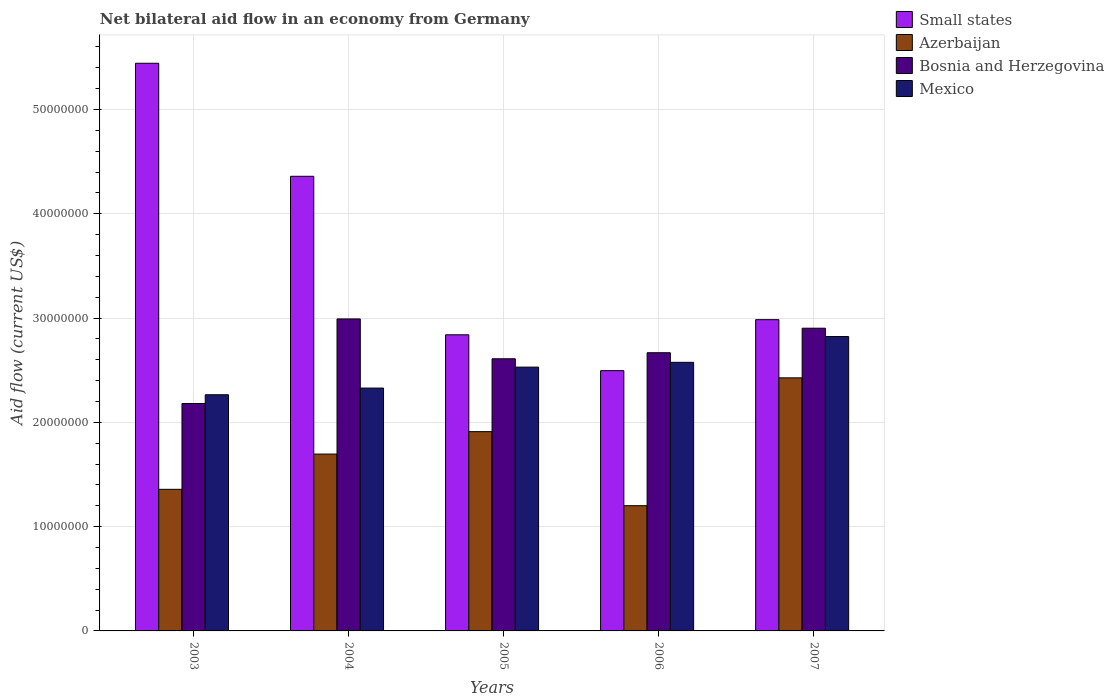How many different coloured bars are there?
Keep it short and to the point. 4. How many bars are there on the 3rd tick from the left?
Your answer should be compact. 4. What is the label of the 1st group of bars from the left?
Offer a very short reply. 2003. In how many cases, is the number of bars for a given year not equal to the number of legend labels?
Provide a succinct answer. 0. What is the net bilateral aid flow in Small states in 2006?
Keep it short and to the point. 2.50e+07. Across all years, what is the maximum net bilateral aid flow in Small states?
Give a very brief answer. 5.44e+07. Across all years, what is the minimum net bilateral aid flow in Small states?
Provide a short and direct response. 2.50e+07. What is the total net bilateral aid flow in Small states in the graph?
Ensure brevity in your answer.  1.81e+08. What is the difference between the net bilateral aid flow in Azerbaijan in 2003 and that in 2006?
Your answer should be very brief. 1.57e+06. What is the difference between the net bilateral aid flow in Mexico in 2005 and the net bilateral aid flow in Bosnia and Herzegovina in 2004?
Provide a short and direct response. -4.62e+06. What is the average net bilateral aid flow in Mexico per year?
Keep it short and to the point. 2.50e+07. In the year 2004, what is the difference between the net bilateral aid flow in Azerbaijan and net bilateral aid flow in Mexico?
Your answer should be very brief. -6.33e+06. In how many years, is the net bilateral aid flow in Bosnia and Herzegovina greater than 16000000 US$?
Make the answer very short. 5. What is the ratio of the net bilateral aid flow in Bosnia and Herzegovina in 2004 to that in 2006?
Your answer should be compact. 1.12. Is the net bilateral aid flow in Bosnia and Herzegovina in 2005 less than that in 2006?
Offer a terse response. Yes. What is the difference between the highest and the second highest net bilateral aid flow in Bosnia and Herzegovina?
Make the answer very short. 8.90e+05. What is the difference between the highest and the lowest net bilateral aid flow in Mexico?
Your answer should be very brief. 5.58e+06. In how many years, is the net bilateral aid flow in Small states greater than the average net bilateral aid flow in Small states taken over all years?
Provide a short and direct response. 2. Is the sum of the net bilateral aid flow in Small states in 2006 and 2007 greater than the maximum net bilateral aid flow in Azerbaijan across all years?
Ensure brevity in your answer.  Yes. Is it the case that in every year, the sum of the net bilateral aid flow in Bosnia and Herzegovina and net bilateral aid flow in Small states is greater than the sum of net bilateral aid flow in Mexico and net bilateral aid flow in Azerbaijan?
Provide a succinct answer. Yes. What does the 4th bar from the left in 2005 represents?
Give a very brief answer. Mexico. What does the 3rd bar from the right in 2007 represents?
Your response must be concise. Azerbaijan. Are all the bars in the graph horizontal?
Keep it short and to the point. No. Are the values on the major ticks of Y-axis written in scientific E-notation?
Your answer should be compact. No. Does the graph contain grids?
Ensure brevity in your answer.  Yes. How many legend labels are there?
Provide a succinct answer. 4. How are the legend labels stacked?
Offer a very short reply. Vertical. What is the title of the graph?
Your answer should be very brief. Net bilateral aid flow in an economy from Germany. What is the label or title of the Y-axis?
Keep it short and to the point. Aid flow (current US$). What is the Aid flow (current US$) of Small states in 2003?
Your response must be concise. 5.44e+07. What is the Aid flow (current US$) in Azerbaijan in 2003?
Offer a terse response. 1.36e+07. What is the Aid flow (current US$) of Bosnia and Herzegovina in 2003?
Your response must be concise. 2.18e+07. What is the Aid flow (current US$) of Mexico in 2003?
Provide a succinct answer. 2.26e+07. What is the Aid flow (current US$) of Small states in 2004?
Ensure brevity in your answer.  4.36e+07. What is the Aid flow (current US$) of Azerbaijan in 2004?
Ensure brevity in your answer.  1.70e+07. What is the Aid flow (current US$) in Bosnia and Herzegovina in 2004?
Keep it short and to the point. 2.99e+07. What is the Aid flow (current US$) in Mexico in 2004?
Give a very brief answer. 2.33e+07. What is the Aid flow (current US$) in Small states in 2005?
Keep it short and to the point. 2.84e+07. What is the Aid flow (current US$) of Azerbaijan in 2005?
Offer a terse response. 1.91e+07. What is the Aid flow (current US$) in Bosnia and Herzegovina in 2005?
Provide a short and direct response. 2.61e+07. What is the Aid flow (current US$) in Mexico in 2005?
Give a very brief answer. 2.53e+07. What is the Aid flow (current US$) in Small states in 2006?
Provide a succinct answer. 2.50e+07. What is the Aid flow (current US$) of Azerbaijan in 2006?
Provide a succinct answer. 1.20e+07. What is the Aid flow (current US$) in Bosnia and Herzegovina in 2006?
Offer a very short reply. 2.67e+07. What is the Aid flow (current US$) of Mexico in 2006?
Provide a short and direct response. 2.58e+07. What is the Aid flow (current US$) in Small states in 2007?
Your response must be concise. 2.98e+07. What is the Aid flow (current US$) of Azerbaijan in 2007?
Make the answer very short. 2.43e+07. What is the Aid flow (current US$) in Bosnia and Herzegovina in 2007?
Make the answer very short. 2.90e+07. What is the Aid flow (current US$) of Mexico in 2007?
Offer a terse response. 2.82e+07. Across all years, what is the maximum Aid flow (current US$) of Small states?
Your answer should be very brief. 5.44e+07. Across all years, what is the maximum Aid flow (current US$) of Azerbaijan?
Provide a succinct answer. 2.43e+07. Across all years, what is the maximum Aid flow (current US$) of Bosnia and Herzegovina?
Give a very brief answer. 2.99e+07. Across all years, what is the maximum Aid flow (current US$) of Mexico?
Make the answer very short. 2.82e+07. Across all years, what is the minimum Aid flow (current US$) of Small states?
Ensure brevity in your answer.  2.50e+07. Across all years, what is the minimum Aid flow (current US$) of Azerbaijan?
Make the answer very short. 1.20e+07. Across all years, what is the minimum Aid flow (current US$) in Bosnia and Herzegovina?
Your answer should be compact. 2.18e+07. Across all years, what is the minimum Aid flow (current US$) in Mexico?
Give a very brief answer. 2.26e+07. What is the total Aid flow (current US$) in Small states in the graph?
Offer a very short reply. 1.81e+08. What is the total Aid flow (current US$) of Azerbaijan in the graph?
Make the answer very short. 8.59e+07. What is the total Aid flow (current US$) in Bosnia and Herzegovina in the graph?
Make the answer very short. 1.34e+08. What is the total Aid flow (current US$) of Mexico in the graph?
Your answer should be very brief. 1.25e+08. What is the difference between the Aid flow (current US$) in Small states in 2003 and that in 2004?
Offer a very short reply. 1.08e+07. What is the difference between the Aid flow (current US$) in Azerbaijan in 2003 and that in 2004?
Keep it short and to the point. -3.38e+06. What is the difference between the Aid flow (current US$) of Bosnia and Herzegovina in 2003 and that in 2004?
Ensure brevity in your answer.  -8.11e+06. What is the difference between the Aid flow (current US$) of Mexico in 2003 and that in 2004?
Give a very brief answer. -6.40e+05. What is the difference between the Aid flow (current US$) of Small states in 2003 and that in 2005?
Provide a short and direct response. 2.60e+07. What is the difference between the Aid flow (current US$) in Azerbaijan in 2003 and that in 2005?
Give a very brief answer. -5.53e+06. What is the difference between the Aid flow (current US$) in Bosnia and Herzegovina in 2003 and that in 2005?
Make the answer very short. -4.29e+06. What is the difference between the Aid flow (current US$) of Mexico in 2003 and that in 2005?
Your answer should be compact. -2.65e+06. What is the difference between the Aid flow (current US$) in Small states in 2003 and that in 2006?
Your answer should be compact. 2.95e+07. What is the difference between the Aid flow (current US$) in Azerbaijan in 2003 and that in 2006?
Give a very brief answer. 1.57e+06. What is the difference between the Aid flow (current US$) in Bosnia and Herzegovina in 2003 and that in 2006?
Give a very brief answer. -4.87e+06. What is the difference between the Aid flow (current US$) in Mexico in 2003 and that in 2006?
Your answer should be compact. -3.11e+06. What is the difference between the Aid flow (current US$) in Small states in 2003 and that in 2007?
Give a very brief answer. 2.46e+07. What is the difference between the Aid flow (current US$) in Azerbaijan in 2003 and that in 2007?
Make the answer very short. -1.07e+07. What is the difference between the Aid flow (current US$) of Bosnia and Herzegovina in 2003 and that in 2007?
Offer a terse response. -7.22e+06. What is the difference between the Aid flow (current US$) in Mexico in 2003 and that in 2007?
Keep it short and to the point. -5.58e+06. What is the difference between the Aid flow (current US$) of Small states in 2004 and that in 2005?
Your response must be concise. 1.52e+07. What is the difference between the Aid flow (current US$) in Azerbaijan in 2004 and that in 2005?
Keep it short and to the point. -2.15e+06. What is the difference between the Aid flow (current US$) in Bosnia and Herzegovina in 2004 and that in 2005?
Offer a terse response. 3.82e+06. What is the difference between the Aid flow (current US$) of Mexico in 2004 and that in 2005?
Ensure brevity in your answer.  -2.01e+06. What is the difference between the Aid flow (current US$) of Small states in 2004 and that in 2006?
Your answer should be compact. 1.86e+07. What is the difference between the Aid flow (current US$) in Azerbaijan in 2004 and that in 2006?
Make the answer very short. 4.95e+06. What is the difference between the Aid flow (current US$) of Bosnia and Herzegovina in 2004 and that in 2006?
Provide a succinct answer. 3.24e+06. What is the difference between the Aid flow (current US$) of Mexico in 2004 and that in 2006?
Provide a succinct answer. -2.47e+06. What is the difference between the Aid flow (current US$) in Small states in 2004 and that in 2007?
Keep it short and to the point. 1.38e+07. What is the difference between the Aid flow (current US$) in Azerbaijan in 2004 and that in 2007?
Offer a very short reply. -7.31e+06. What is the difference between the Aid flow (current US$) in Bosnia and Herzegovina in 2004 and that in 2007?
Offer a terse response. 8.90e+05. What is the difference between the Aid flow (current US$) of Mexico in 2004 and that in 2007?
Give a very brief answer. -4.94e+06. What is the difference between the Aid flow (current US$) of Small states in 2005 and that in 2006?
Offer a very short reply. 3.44e+06. What is the difference between the Aid flow (current US$) of Azerbaijan in 2005 and that in 2006?
Offer a very short reply. 7.10e+06. What is the difference between the Aid flow (current US$) in Bosnia and Herzegovina in 2005 and that in 2006?
Offer a very short reply. -5.80e+05. What is the difference between the Aid flow (current US$) in Mexico in 2005 and that in 2006?
Keep it short and to the point. -4.60e+05. What is the difference between the Aid flow (current US$) in Small states in 2005 and that in 2007?
Provide a succinct answer. -1.45e+06. What is the difference between the Aid flow (current US$) of Azerbaijan in 2005 and that in 2007?
Your answer should be compact. -5.16e+06. What is the difference between the Aid flow (current US$) of Bosnia and Herzegovina in 2005 and that in 2007?
Provide a succinct answer. -2.93e+06. What is the difference between the Aid flow (current US$) in Mexico in 2005 and that in 2007?
Your response must be concise. -2.93e+06. What is the difference between the Aid flow (current US$) of Small states in 2006 and that in 2007?
Your answer should be very brief. -4.89e+06. What is the difference between the Aid flow (current US$) of Azerbaijan in 2006 and that in 2007?
Make the answer very short. -1.23e+07. What is the difference between the Aid flow (current US$) of Bosnia and Herzegovina in 2006 and that in 2007?
Provide a short and direct response. -2.35e+06. What is the difference between the Aid flow (current US$) in Mexico in 2006 and that in 2007?
Provide a succinct answer. -2.47e+06. What is the difference between the Aid flow (current US$) of Small states in 2003 and the Aid flow (current US$) of Azerbaijan in 2004?
Your answer should be very brief. 3.75e+07. What is the difference between the Aid flow (current US$) of Small states in 2003 and the Aid flow (current US$) of Bosnia and Herzegovina in 2004?
Provide a succinct answer. 2.45e+07. What is the difference between the Aid flow (current US$) in Small states in 2003 and the Aid flow (current US$) in Mexico in 2004?
Offer a terse response. 3.12e+07. What is the difference between the Aid flow (current US$) of Azerbaijan in 2003 and the Aid flow (current US$) of Bosnia and Herzegovina in 2004?
Your response must be concise. -1.63e+07. What is the difference between the Aid flow (current US$) in Azerbaijan in 2003 and the Aid flow (current US$) in Mexico in 2004?
Provide a short and direct response. -9.71e+06. What is the difference between the Aid flow (current US$) of Bosnia and Herzegovina in 2003 and the Aid flow (current US$) of Mexico in 2004?
Ensure brevity in your answer.  -1.48e+06. What is the difference between the Aid flow (current US$) of Small states in 2003 and the Aid flow (current US$) of Azerbaijan in 2005?
Ensure brevity in your answer.  3.53e+07. What is the difference between the Aid flow (current US$) in Small states in 2003 and the Aid flow (current US$) in Bosnia and Herzegovina in 2005?
Offer a very short reply. 2.83e+07. What is the difference between the Aid flow (current US$) of Small states in 2003 and the Aid flow (current US$) of Mexico in 2005?
Give a very brief answer. 2.91e+07. What is the difference between the Aid flow (current US$) of Azerbaijan in 2003 and the Aid flow (current US$) of Bosnia and Herzegovina in 2005?
Your answer should be very brief. -1.25e+07. What is the difference between the Aid flow (current US$) in Azerbaijan in 2003 and the Aid flow (current US$) in Mexico in 2005?
Ensure brevity in your answer.  -1.17e+07. What is the difference between the Aid flow (current US$) of Bosnia and Herzegovina in 2003 and the Aid flow (current US$) of Mexico in 2005?
Ensure brevity in your answer.  -3.49e+06. What is the difference between the Aid flow (current US$) of Small states in 2003 and the Aid flow (current US$) of Azerbaijan in 2006?
Make the answer very short. 4.24e+07. What is the difference between the Aid flow (current US$) of Small states in 2003 and the Aid flow (current US$) of Bosnia and Herzegovina in 2006?
Your response must be concise. 2.78e+07. What is the difference between the Aid flow (current US$) in Small states in 2003 and the Aid flow (current US$) in Mexico in 2006?
Make the answer very short. 2.87e+07. What is the difference between the Aid flow (current US$) of Azerbaijan in 2003 and the Aid flow (current US$) of Bosnia and Herzegovina in 2006?
Offer a terse response. -1.31e+07. What is the difference between the Aid flow (current US$) of Azerbaijan in 2003 and the Aid flow (current US$) of Mexico in 2006?
Give a very brief answer. -1.22e+07. What is the difference between the Aid flow (current US$) in Bosnia and Herzegovina in 2003 and the Aid flow (current US$) in Mexico in 2006?
Offer a very short reply. -3.95e+06. What is the difference between the Aid flow (current US$) in Small states in 2003 and the Aid flow (current US$) in Azerbaijan in 2007?
Provide a short and direct response. 3.02e+07. What is the difference between the Aid flow (current US$) in Small states in 2003 and the Aid flow (current US$) in Bosnia and Herzegovina in 2007?
Ensure brevity in your answer.  2.54e+07. What is the difference between the Aid flow (current US$) of Small states in 2003 and the Aid flow (current US$) of Mexico in 2007?
Offer a terse response. 2.62e+07. What is the difference between the Aid flow (current US$) in Azerbaijan in 2003 and the Aid flow (current US$) in Bosnia and Herzegovina in 2007?
Offer a very short reply. -1.54e+07. What is the difference between the Aid flow (current US$) in Azerbaijan in 2003 and the Aid flow (current US$) in Mexico in 2007?
Your response must be concise. -1.46e+07. What is the difference between the Aid flow (current US$) in Bosnia and Herzegovina in 2003 and the Aid flow (current US$) in Mexico in 2007?
Keep it short and to the point. -6.42e+06. What is the difference between the Aid flow (current US$) of Small states in 2004 and the Aid flow (current US$) of Azerbaijan in 2005?
Your answer should be very brief. 2.45e+07. What is the difference between the Aid flow (current US$) in Small states in 2004 and the Aid flow (current US$) in Bosnia and Herzegovina in 2005?
Provide a succinct answer. 1.75e+07. What is the difference between the Aid flow (current US$) of Small states in 2004 and the Aid flow (current US$) of Mexico in 2005?
Offer a terse response. 1.83e+07. What is the difference between the Aid flow (current US$) of Azerbaijan in 2004 and the Aid flow (current US$) of Bosnia and Herzegovina in 2005?
Offer a terse response. -9.14e+06. What is the difference between the Aid flow (current US$) of Azerbaijan in 2004 and the Aid flow (current US$) of Mexico in 2005?
Give a very brief answer. -8.34e+06. What is the difference between the Aid flow (current US$) of Bosnia and Herzegovina in 2004 and the Aid flow (current US$) of Mexico in 2005?
Provide a succinct answer. 4.62e+06. What is the difference between the Aid flow (current US$) of Small states in 2004 and the Aid flow (current US$) of Azerbaijan in 2006?
Keep it short and to the point. 3.16e+07. What is the difference between the Aid flow (current US$) of Small states in 2004 and the Aid flow (current US$) of Bosnia and Herzegovina in 2006?
Make the answer very short. 1.69e+07. What is the difference between the Aid flow (current US$) in Small states in 2004 and the Aid flow (current US$) in Mexico in 2006?
Your answer should be compact. 1.78e+07. What is the difference between the Aid flow (current US$) in Azerbaijan in 2004 and the Aid flow (current US$) in Bosnia and Herzegovina in 2006?
Keep it short and to the point. -9.72e+06. What is the difference between the Aid flow (current US$) in Azerbaijan in 2004 and the Aid flow (current US$) in Mexico in 2006?
Offer a very short reply. -8.80e+06. What is the difference between the Aid flow (current US$) of Bosnia and Herzegovina in 2004 and the Aid flow (current US$) of Mexico in 2006?
Offer a very short reply. 4.16e+06. What is the difference between the Aid flow (current US$) in Small states in 2004 and the Aid flow (current US$) in Azerbaijan in 2007?
Provide a short and direct response. 1.93e+07. What is the difference between the Aid flow (current US$) of Small states in 2004 and the Aid flow (current US$) of Bosnia and Herzegovina in 2007?
Offer a very short reply. 1.46e+07. What is the difference between the Aid flow (current US$) of Small states in 2004 and the Aid flow (current US$) of Mexico in 2007?
Keep it short and to the point. 1.54e+07. What is the difference between the Aid flow (current US$) in Azerbaijan in 2004 and the Aid flow (current US$) in Bosnia and Herzegovina in 2007?
Your answer should be compact. -1.21e+07. What is the difference between the Aid flow (current US$) in Azerbaijan in 2004 and the Aid flow (current US$) in Mexico in 2007?
Ensure brevity in your answer.  -1.13e+07. What is the difference between the Aid flow (current US$) in Bosnia and Herzegovina in 2004 and the Aid flow (current US$) in Mexico in 2007?
Your response must be concise. 1.69e+06. What is the difference between the Aid flow (current US$) in Small states in 2005 and the Aid flow (current US$) in Azerbaijan in 2006?
Keep it short and to the point. 1.64e+07. What is the difference between the Aid flow (current US$) in Small states in 2005 and the Aid flow (current US$) in Bosnia and Herzegovina in 2006?
Keep it short and to the point. 1.72e+06. What is the difference between the Aid flow (current US$) in Small states in 2005 and the Aid flow (current US$) in Mexico in 2006?
Keep it short and to the point. 2.64e+06. What is the difference between the Aid flow (current US$) in Azerbaijan in 2005 and the Aid flow (current US$) in Bosnia and Herzegovina in 2006?
Your response must be concise. -7.57e+06. What is the difference between the Aid flow (current US$) in Azerbaijan in 2005 and the Aid flow (current US$) in Mexico in 2006?
Keep it short and to the point. -6.65e+06. What is the difference between the Aid flow (current US$) in Small states in 2005 and the Aid flow (current US$) in Azerbaijan in 2007?
Provide a short and direct response. 4.13e+06. What is the difference between the Aid flow (current US$) of Small states in 2005 and the Aid flow (current US$) of Bosnia and Herzegovina in 2007?
Provide a short and direct response. -6.30e+05. What is the difference between the Aid flow (current US$) of Azerbaijan in 2005 and the Aid flow (current US$) of Bosnia and Herzegovina in 2007?
Ensure brevity in your answer.  -9.92e+06. What is the difference between the Aid flow (current US$) of Azerbaijan in 2005 and the Aid flow (current US$) of Mexico in 2007?
Offer a terse response. -9.12e+06. What is the difference between the Aid flow (current US$) of Bosnia and Herzegovina in 2005 and the Aid flow (current US$) of Mexico in 2007?
Offer a very short reply. -2.13e+06. What is the difference between the Aid flow (current US$) of Small states in 2006 and the Aid flow (current US$) of Azerbaijan in 2007?
Provide a short and direct response. 6.90e+05. What is the difference between the Aid flow (current US$) of Small states in 2006 and the Aid flow (current US$) of Bosnia and Herzegovina in 2007?
Keep it short and to the point. -4.07e+06. What is the difference between the Aid flow (current US$) of Small states in 2006 and the Aid flow (current US$) of Mexico in 2007?
Make the answer very short. -3.27e+06. What is the difference between the Aid flow (current US$) in Azerbaijan in 2006 and the Aid flow (current US$) in Bosnia and Herzegovina in 2007?
Your answer should be compact. -1.70e+07. What is the difference between the Aid flow (current US$) of Azerbaijan in 2006 and the Aid flow (current US$) of Mexico in 2007?
Offer a terse response. -1.62e+07. What is the difference between the Aid flow (current US$) of Bosnia and Herzegovina in 2006 and the Aid flow (current US$) of Mexico in 2007?
Provide a succinct answer. -1.55e+06. What is the average Aid flow (current US$) of Small states per year?
Your answer should be very brief. 3.62e+07. What is the average Aid flow (current US$) of Azerbaijan per year?
Keep it short and to the point. 1.72e+07. What is the average Aid flow (current US$) in Bosnia and Herzegovina per year?
Provide a short and direct response. 2.67e+07. What is the average Aid flow (current US$) of Mexico per year?
Provide a short and direct response. 2.50e+07. In the year 2003, what is the difference between the Aid flow (current US$) in Small states and Aid flow (current US$) in Azerbaijan?
Keep it short and to the point. 4.09e+07. In the year 2003, what is the difference between the Aid flow (current US$) of Small states and Aid flow (current US$) of Bosnia and Herzegovina?
Make the answer very short. 3.26e+07. In the year 2003, what is the difference between the Aid flow (current US$) in Small states and Aid flow (current US$) in Mexico?
Keep it short and to the point. 3.18e+07. In the year 2003, what is the difference between the Aid flow (current US$) in Azerbaijan and Aid flow (current US$) in Bosnia and Herzegovina?
Offer a terse response. -8.23e+06. In the year 2003, what is the difference between the Aid flow (current US$) in Azerbaijan and Aid flow (current US$) in Mexico?
Offer a very short reply. -9.07e+06. In the year 2003, what is the difference between the Aid flow (current US$) of Bosnia and Herzegovina and Aid flow (current US$) of Mexico?
Provide a succinct answer. -8.40e+05. In the year 2004, what is the difference between the Aid flow (current US$) in Small states and Aid flow (current US$) in Azerbaijan?
Keep it short and to the point. 2.66e+07. In the year 2004, what is the difference between the Aid flow (current US$) of Small states and Aid flow (current US$) of Bosnia and Herzegovina?
Your response must be concise. 1.37e+07. In the year 2004, what is the difference between the Aid flow (current US$) of Small states and Aid flow (current US$) of Mexico?
Provide a short and direct response. 2.03e+07. In the year 2004, what is the difference between the Aid flow (current US$) of Azerbaijan and Aid flow (current US$) of Bosnia and Herzegovina?
Offer a very short reply. -1.30e+07. In the year 2004, what is the difference between the Aid flow (current US$) in Azerbaijan and Aid flow (current US$) in Mexico?
Make the answer very short. -6.33e+06. In the year 2004, what is the difference between the Aid flow (current US$) in Bosnia and Herzegovina and Aid flow (current US$) in Mexico?
Make the answer very short. 6.63e+06. In the year 2005, what is the difference between the Aid flow (current US$) of Small states and Aid flow (current US$) of Azerbaijan?
Offer a terse response. 9.29e+06. In the year 2005, what is the difference between the Aid flow (current US$) in Small states and Aid flow (current US$) in Bosnia and Herzegovina?
Give a very brief answer. 2.30e+06. In the year 2005, what is the difference between the Aid flow (current US$) in Small states and Aid flow (current US$) in Mexico?
Your answer should be very brief. 3.10e+06. In the year 2005, what is the difference between the Aid flow (current US$) of Azerbaijan and Aid flow (current US$) of Bosnia and Herzegovina?
Your response must be concise. -6.99e+06. In the year 2005, what is the difference between the Aid flow (current US$) of Azerbaijan and Aid flow (current US$) of Mexico?
Offer a terse response. -6.19e+06. In the year 2005, what is the difference between the Aid flow (current US$) in Bosnia and Herzegovina and Aid flow (current US$) in Mexico?
Offer a very short reply. 8.00e+05. In the year 2006, what is the difference between the Aid flow (current US$) in Small states and Aid flow (current US$) in Azerbaijan?
Keep it short and to the point. 1.30e+07. In the year 2006, what is the difference between the Aid flow (current US$) of Small states and Aid flow (current US$) of Bosnia and Herzegovina?
Offer a terse response. -1.72e+06. In the year 2006, what is the difference between the Aid flow (current US$) in Small states and Aid flow (current US$) in Mexico?
Offer a very short reply. -8.00e+05. In the year 2006, what is the difference between the Aid flow (current US$) of Azerbaijan and Aid flow (current US$) of Bosnia and Herzegovina?
Your response must be concise. -1.47e+07. In the year 2006, what is the difference between the Aid flow (current US$) of Azerbaijan and Aid flow (current US$) of Mexico?
Provide a short and direct response. -1.38e+07. In the year 2006, what is the difference between the Aid flow (current US$) in Bosnia and Herzegovina and Aid flow (current US$) in Mexico?
Provide a short and direct response. 9.20e+05. In the year 2007, what is the difference between the Aid flow (current US$) of Small states and Aid flow (current US$) of Azerbaijan?
Your response must be concise. 5.58e+06. In the year 2007, what is the difference between the Aid flow (current US$) in Small states and Aid flow (current US$) in Bosnia and Herzegovina?
Offer a terse response. 8.20e+05. In the year 2007, what is the difference between the Aid flow (current US$) of Small states and Aid flow (current US$) of Mexico?
Ensure brevity in your answer.  1.62e+06. In the year 2007, what is the difference between the Aid flow (current US$) in Azerbaijan and Aid flow (current US$) in Bosnia and Herzegovina?
Offer a terse response. -4.76e+06. In the year 2007, what is the difference between the Aid flow (current US$) of Azerbaijan and Aid flow (current US$) of Mexico?
Provide a succinct answer. -3.96e+06. In the year 2007, what is the difference between the Aid flow (current US$) of Bosnia and Herzegovina and Aid flow (current US$) of Mexico?
Your answer should be very brief. 8.00e+05. What is the ratio of the Aid flow (current US$) of Small states in 2003 to that in 2004?
Keep it short and to the point. 1.25. What is the ratio of the Aid flow (current US$) of Azerbaijan in 2003 to that in 2004?
Provide a succinct answer. 0.8. What is the ratio of the Aid flow (current US$) in Bosnia and Herzegovina in 2003 to that in 2004?
Keep it short and to the point. 0.73. What is the ratio of the Aid flow (current US$) of Mexico in 2003 to that in 2004?
Your answer should be compact. 0.97. What is the ratio of the Aid flow (current US$) in Small states in 2003 to that in 2005?
Your answer should be compact. 1.92. What is the ratio of the Aid flow (current US$) of Azerbaijan in 2003 to that in 2005?
Make the answer very short. 0.71. What is the ratio of the Aid flow (current US$) of Bosnia and Herzegovina in 2003 to that in 2005?
Your answer should be compact. 0.84. What is the ratio of the Aid flow (current US$) of Mexico in 2003 to that in 2005?
Offer a very short reply. 0.9. What is the ratio of the Aid flow (current US$) of Small states in 2003 to that in 2006?
Offer a terse response. 2.18. What is the ratio of the Aid flow (current US$) in Azerbaijan in 2003 to that in 2006?
Ensure brevity in your answer.  1.13. What is the ratio of the Aid flow (current US$) of Bosnia and Herzegovina in 2003 to that in 2006?
Make the answer very short. 0.82. What is the ratio of the Aid flow (current US$) in Mexico in 2003 to that in 2006?
Offer a terse response. 0.88. What is the ratio of the Aid flow (current US$) of Small states in 2003 to that in 2007?
Provide a succinct answer. 1.82. What is the ratio of the Aid flow (current US$) in Azerbaijan in 2003 to that in 2007?
Provide a short and direct response. 0.56. What is the ratio of the Aid flow (current US$) in Bosnia and Herzegovina in 2003 to that in 2007?
Keep it short and to the point. 0.75. What is the ratio of the Aid flow (current US$) in Mexico in 2003 to that in 2007?
Give a very brief answer. 0.8. What is the ratio of the Aid flow (current US$) in Small states in 2004 to that in 2005?
Make the answer very short. 1.54. What is the ratio of the Aid flow (current US$) of Azerbaijan in 2004 to that in 2005?
Offer a terse response. 0.89. What is the ratio of the Aid flow (current US$) in Bosnia and Herzegovina in 2004 to that in 2005?
Offer a very short reply. 1.15. What is the ratio of the Aid flow (current US$) of Mexico in 2004 to that in 2005?
Ensure brevity in your answer.  0.92. What is the ratio of the Aid flow (current US$) in Small states in 2004 to that in 2006?
Your answer should be compact. 1.75. What is the ratio of the Aid flow (current US$) in Azerbaijan in 2004 to that in 2006?
Make the answer very short. 1.41. What is the ratio of the Aid flow (current US$) of Bosnia and Herzegovina in 2004 to that in 2006?
Give a very brief answer. 1.12. What is the ratio of the Aid flow (current US$) of Mexico in 2004 to that in 2006?
Offer a terse response. 0.9. What is the ratio of the Aid flow (current US$) in Small states in 2004 to that in 2007?
Your response must be concise. 1.46. What is the ratio of the Aid flow (current US$) in Azerbaijan in 2004 to that in 2007?
Your response must be concise. 0.7. What is the ratio of the Aid flow (current US$) in Bosnia and Herzegovina in 2004 to that in 2007?
Ensure brevity in your answer.  1.03. What is the ratio of the Aid flow (current US$) of Mexico in 2004 to that in 2007?
Offer a terse response. 0.82. What is the ratio of the Aid flow (current US$) in Small states in 2005 to that in 2006?
Provide a succinct answer. 1.14. What is the ratio of the Aid flow (current US$) of Azerbaijan in 2005 to that in 2006?
Offer a very short reply. 1.59. What is the ratio of the Aid flow (current US$) in Bosnia and Herzegovina in 2005 to that in 2006?
Provide a short and direct response. 0.98. What is the ratio of the Aid flow (current US$) of Mexico in 2005 to that in 2006?
Offer a very short reply. 0.98. What is the ratio of the Aid flow (current US$) of Small states in 2005 to that in 2007?
Offer a terse response. 0.95. What is the ratio of the Aid flow (current US$) of Azerbaijan in 2005 to that in 2007?
Make the answer very short. 0.79. What is the ratio of the Aid flow (current US$) of Bosnia and Herzegovina in 2005 to that in 2007?
Provide a short and direct response. 0.9. What is the ratio of the Aid flow (current US$) in Mexico in 2005 to that in 2007?
Keep it short and to the point. 0.9. What is the ratio of the Aid flow (current US$) of Small states in 2006 to that in 2007?
Offer a very short reply. 0.84. What is the ratio of the Aid flow (current US$) in Azerbaijan in 2006 to that in 2007?
Offer a very short reply. 0.49. What is the ratio of the Aid flow (current US$) in Bosnia and Herzegovina in 2006 to that in 2007?
Your response must be concise. 0.92. What is the ratio of the Aid flow (current US$) in Mexico in 2006 to that in 2007?
Keep it short and to the point. 0.91. What is the difference between the highest and the second highest Aid flow (current US$) of Small states?
Your answer should be very brief. 1.08e+07. What is the difference between the highest and the second highest Aid flow (current US$) in Azerbaijan?
Your response must be concise. 5.16e+06. What is the difference between the highest and the second highest Aid flow (current US$) of Bosnia and Herzegovina?
Offer a terse response. 8.90e+05. What is the difference between the highest and the second highest Aid flow (current US$) in Mexico?
Keep it short and to the point. 2.47e+06. What is the difference between the highest and the lowest Aid flow (current US$) of Small states?
Give a very brief answer. 2.95e+07. What is the difference between the highest and the lowest Aid flow (current US$) of Azerbaijan?
Ensure brevity in your answer.  1.23e+07. What is the difference between the highest and the lowest Aid flow (current US$) in Bosnia and Herzegovina?
Your answer should be very brief. 8.11e+06. What is the difference between the highest and the lowest Aid flow (current US$) of Mexico?
Offer a very short reply. 5.58e+06. 